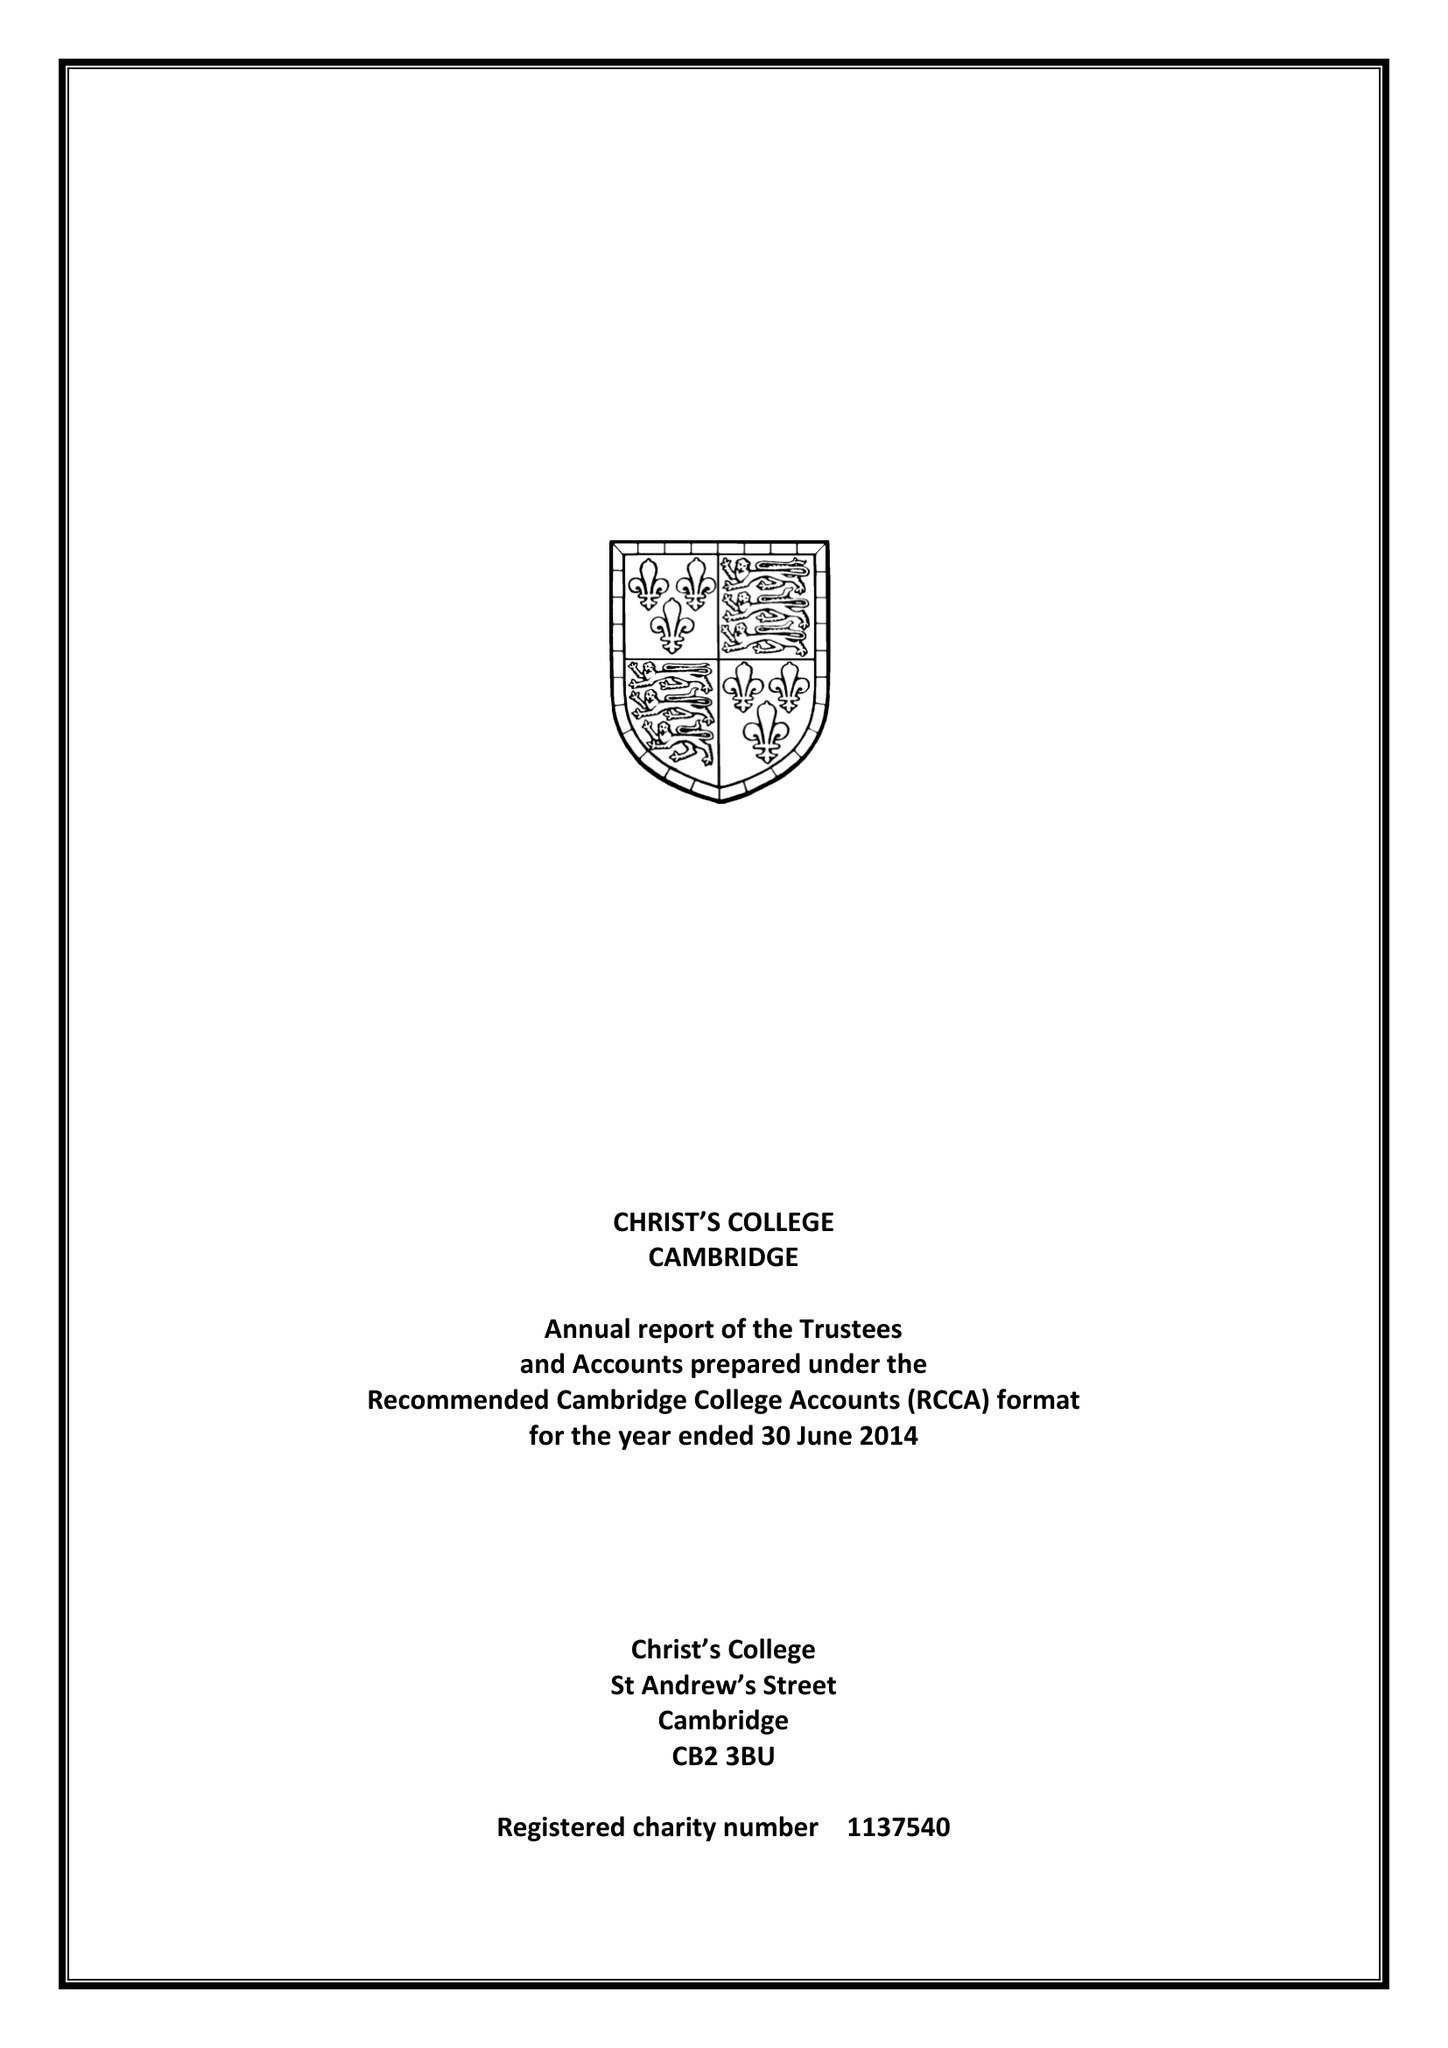What is the value for the report_date?
Answer the question using a single word or phrase. 2014-06-30 